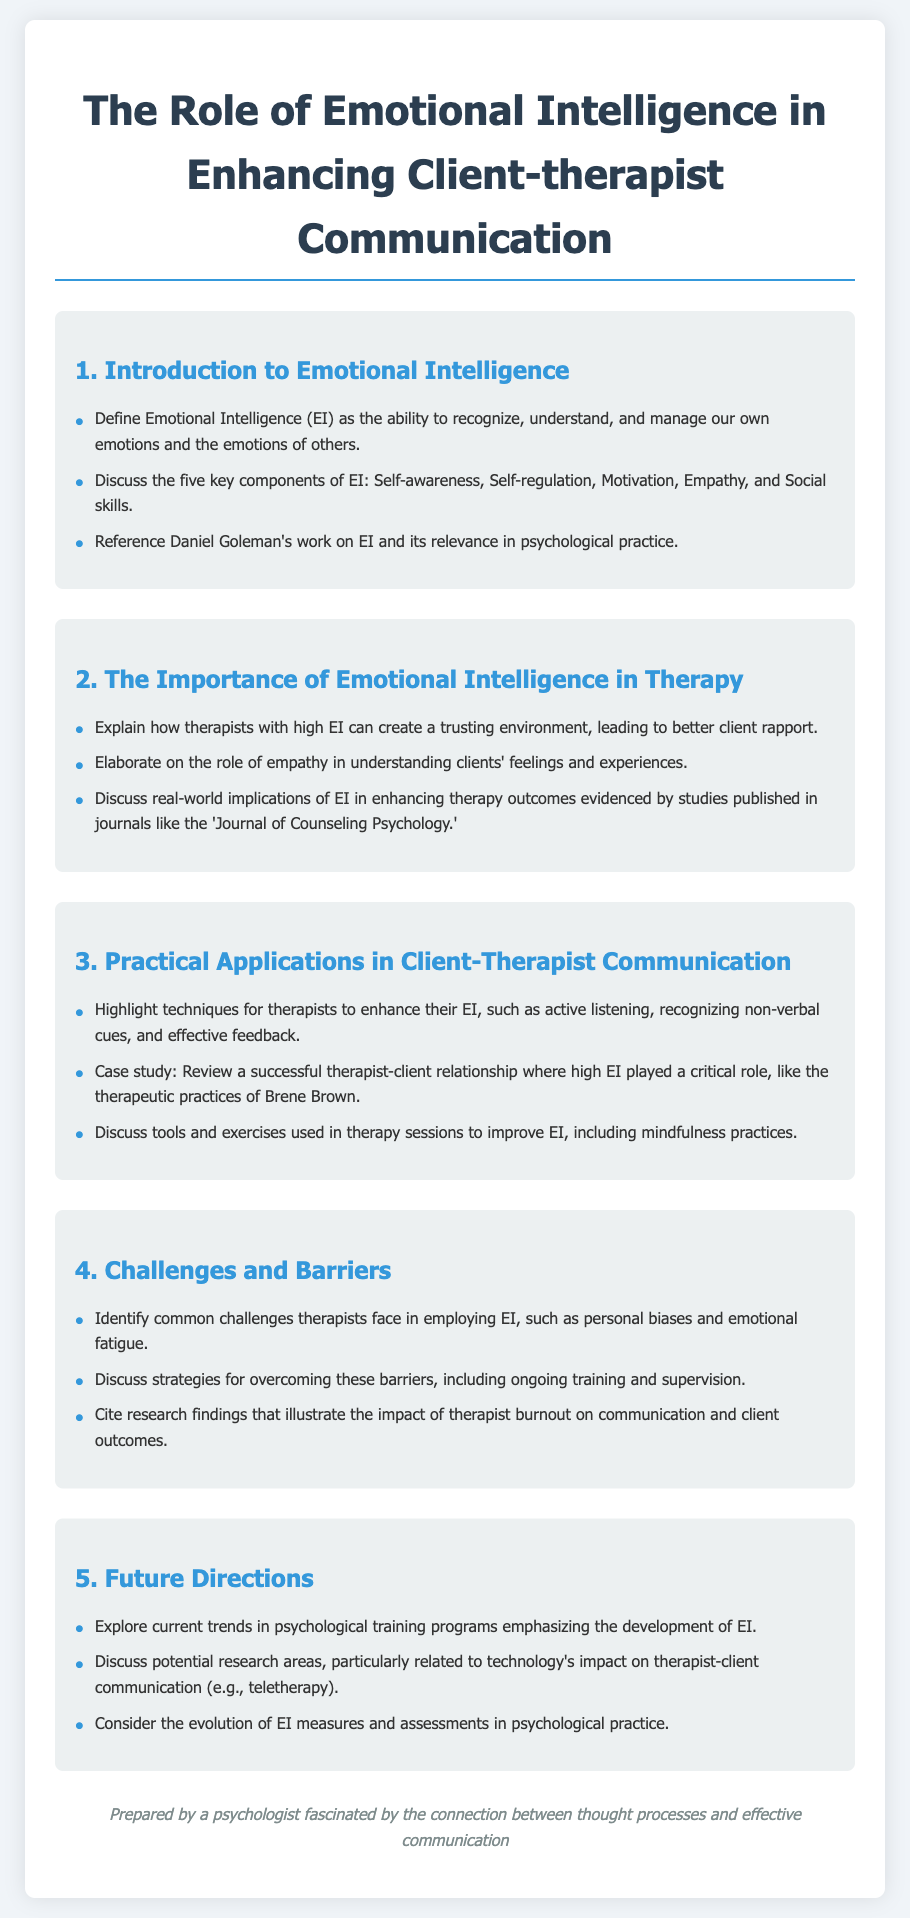What is the title of the document? The title is presented at the top of the document and reflects the main subject discussed within.
Answer: The Role of Emotional Intelligence in Enhancing Client-therapist Communication Who is referenced for their work on Emotional Intelligence? The document mentions the significance of this individual's contributions related to EI in the psychological context.
Answer: Daniel Goleman What are the five key components of Emotional Intelligence? The components are listed in the section discussing the definition of EI, highlighting its various dimensions.
Answer: Self-awareness, Self-regulation, Motivation, Empathy, and Social skills What technique is highlighted for enhancing Emotional Intelligence in therapists? The document provides specific methods used by therapists to improve their EI, indicating practical applications in therapy.
Answer: Active listening In what journal are studies on the implications of EI in therapy published? This journal is mentioned as an example of a publication where relevant studies can be found, reflecting on the document's references.
Answer: Journal of Counseling Psychology What common challenge do therapists face in employing Emotional Intelligence? The document identifies specific barriers that may hinder a therapist’s application of EI in practice.
Answer: Personal biases What is one future direction mentioned regarding psychological training programs? The document outlines potential developments in training supporting the growth of EI, suggesting trends for the future.
Answer: Development of EI What role does emotional fatigue play in therapist-client communication? The document refers to research findings related to therapist well-being and its influence on communication dynamics.
Answer: Impact on communication and client outcomes 